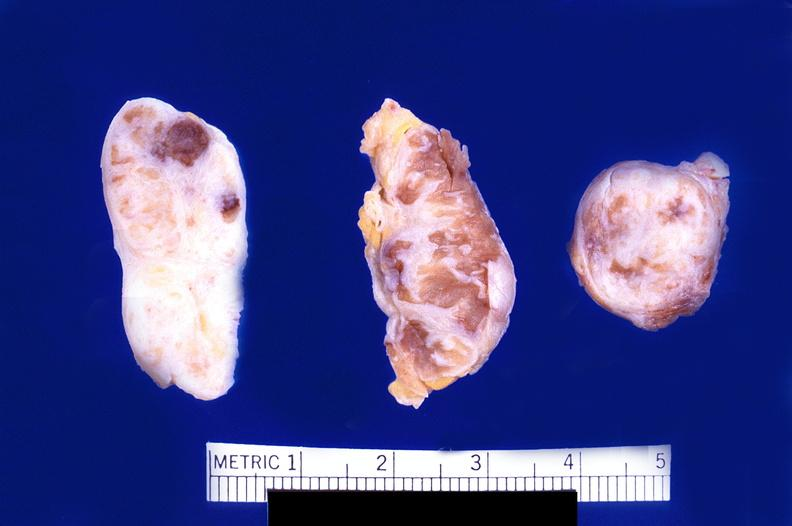does this image show abdominal lymph nodes, nodular sclerosing hodgkins disease?
Answer the question using a single word or phrase. Yes 